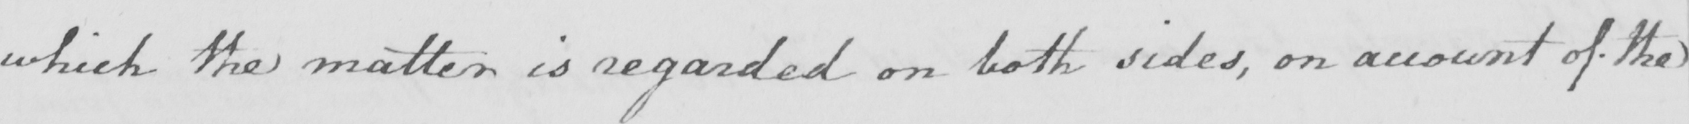Can you tell me what this handwritten text says? which the matter is regarded on both sides , on account of the 